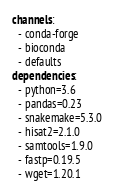Convert code to text. <code><loc_0><loc_0><loc_500><loc_500><_YAML_>channels:
  - conda-forge
  - bioconda
  - defaults
dependencies:
  - python=3.6
  - pandas=0.23
  - snakemake=5.3.0
  - hisat2=2.1.0
  - samtools=1.9.0
  - fastp=0.19.5
  - wget=1.20.1
</code> 